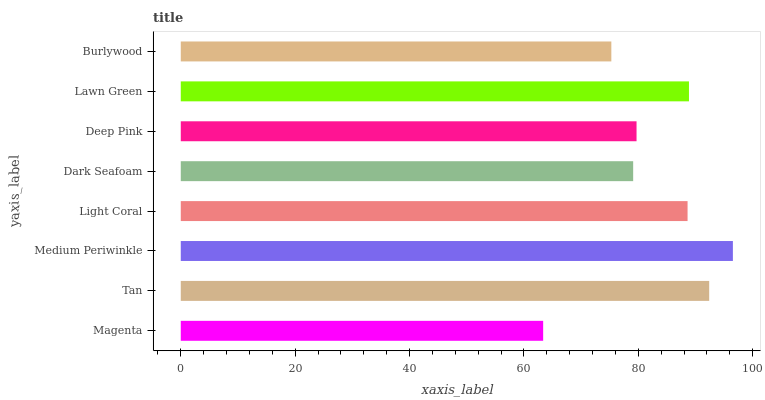Is Magenta the minimum?
Answer yes or no. Yes. Is Medium Periwinkle the maximum?
Answer yes or no. Yes. Is Tan the minimum?
Answer yes or no. No. Is Tan the maximum?
Answer yes or no. No. Is Tan greater than Magenta?
Answer yes or no. Yes. Is Magenta less than Tan?
Answer yes or no. Yes. Is Magenta greater than Tan?
Answer yes or no. No. Is Tan less than Magenta?
Answer yes or no. No. Is Light Coral the high median?
Answer yes or no. Yes. Is Deep Pink the low median?
Answer yes or no. Yes. Is Deep Pink the high median?
Answer yes or no. No. Is Tan the low median?
Answer yes or no. No. 